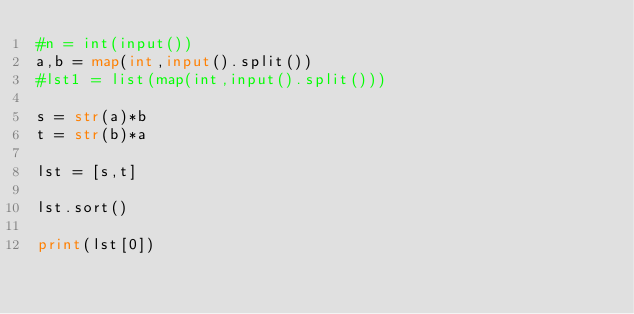Convert code to text. <code><loc_0><loc_0><loc_500><loc_500><_Python_>#n = int(input())
a,b = map(int,input().split())
#lst1 = list(map(int,input().split()))

s = str(a)*b
t = str(b)*a

lst = [s,t]

lst.sort()

print(lst[0])</code> 